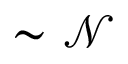Convert formula to latex. <formula><loc_0><loc_0><loc_500><loc_500>\sim \mathcal { N }</formula> 